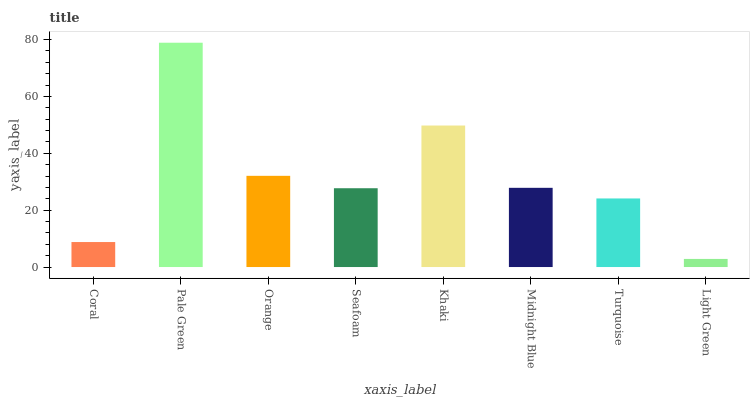Is Light Green the minimum?
Answer yes or no. Yes. Is Pale Green the maximum?
Answer yes or no. Yes. Is Orange the minimum?
Answer yes or no. No. Is Orange the maximum?
Answer yes or no. No. Is Pale Green greater than Orange?
Answer yes or no. Yes. Is Orange less than Pale Green?
Answer yes or no. Yes. Is Orange greater than Pale Green?
Answer yes or no. No. Is Pale Green less than Orange?
Answer yes or no. No. Is Midnight Blue the high median?
Answer yes or no. Yes. Is Seafoam the low median?
Answer yes or no. Yes. Is Pale Green the high median?
Answer yes or no. No. Is Orange the low median?
Answer yes or no. No. 